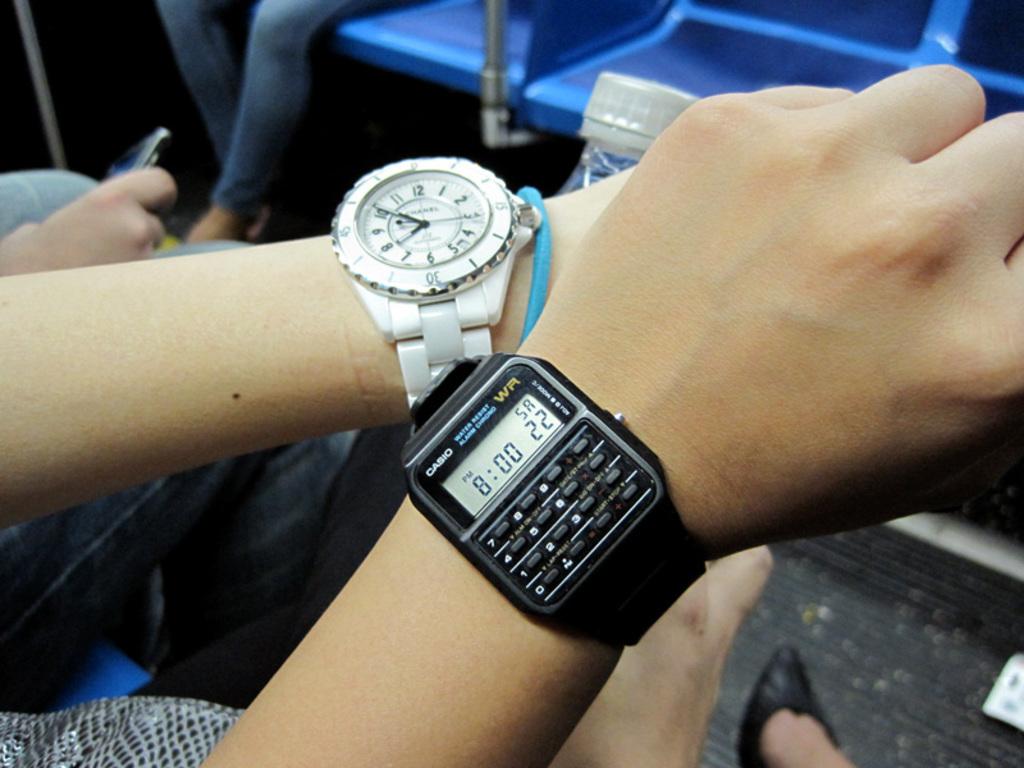What are the two letters in yellow on black watch?
Your response must be concise. Wr. What numbers are on the black watch?
Provide a succinct answer. 8:00 22. 